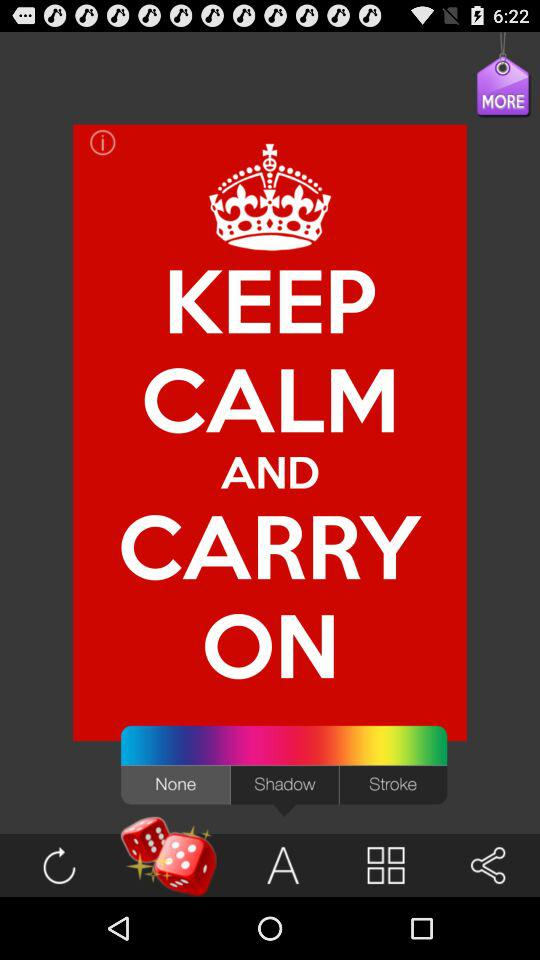Which tab is selected? The selected tab is "Dice". 